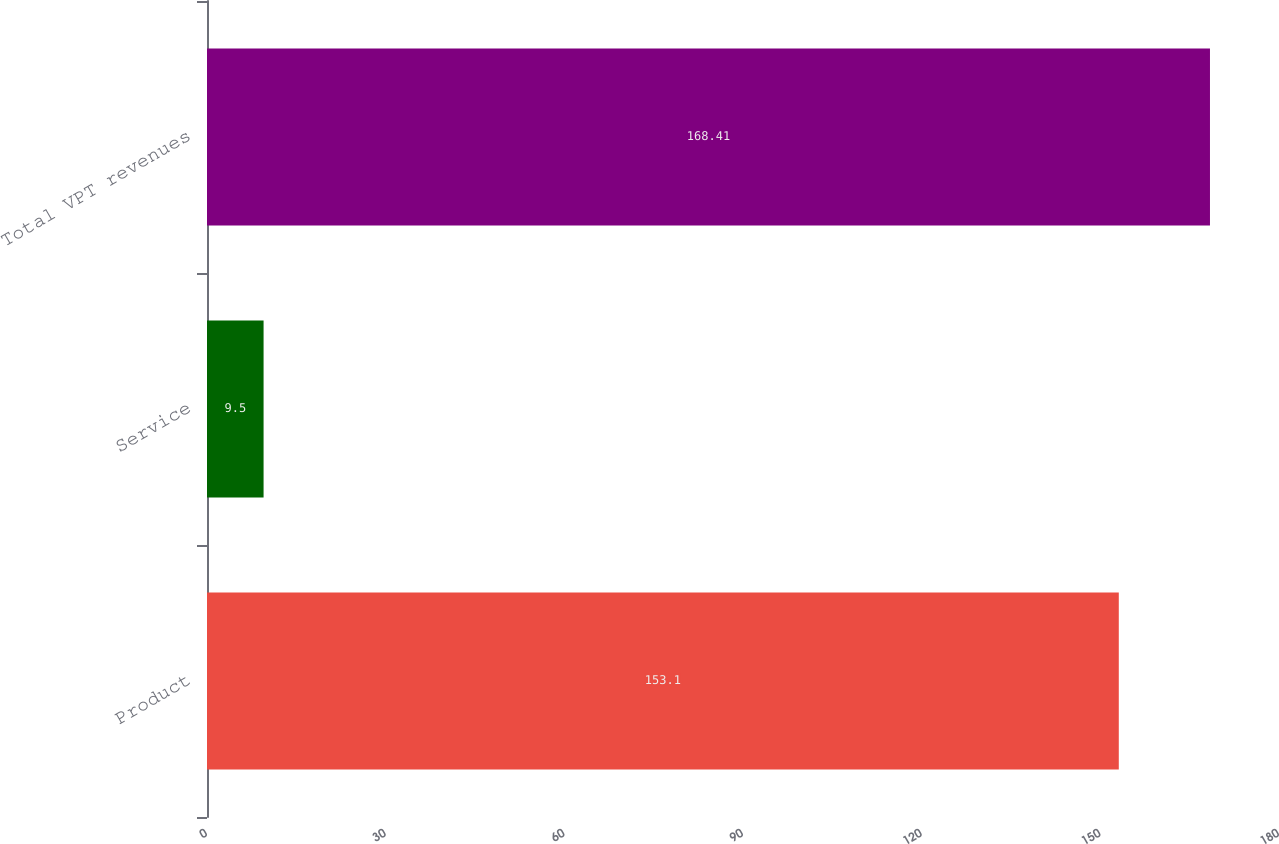<chart> <loc_0><loc_0><loc_500><loc_500><bar_chart><fcel>Product<fcel>Service<fcel>Total VPT revenues<nl><fcel>153.1<fcel>9.5<fcel>168.41<nl></chart> 